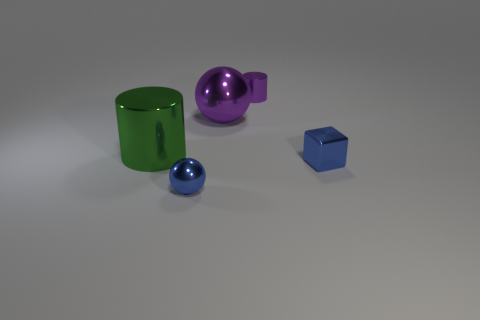Add 1 tiny spheres. How many objects exist? 6 Subtract all cylinders. How many objects are left? 3 Subtract all green things. Subtract all tiny red matte cylinders. How many objects are left? 4 Add 4 green things. How many green things are left? 5 Add 2 blue rubber cubes. How many blue rubber cubes exist? 2 Subtract 0 cyan balls. How many objects are left? 5 